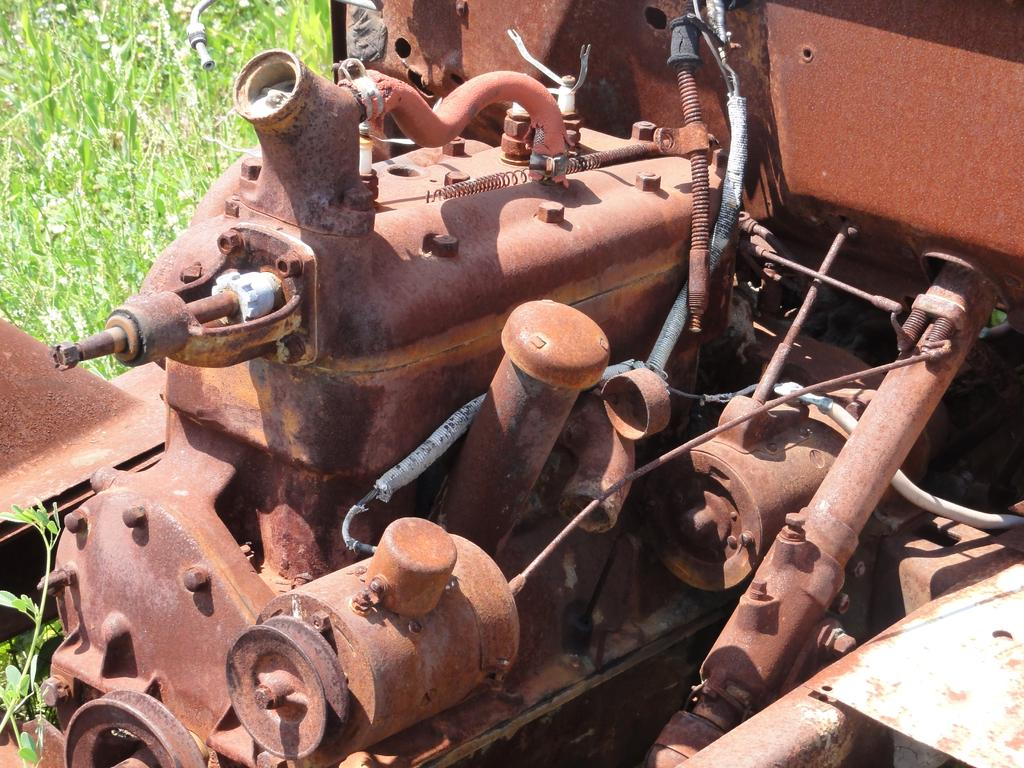What is the main object in the image? There is a machine in the image. What color is the machine? The machine is brown in color. What type of natural environment can be seen in the image? There is green-colored grass visible in the image. What type of brick is being used to build the horn in the image? There is no brick or horn present in the image; it only features a brown machine and green grass. 